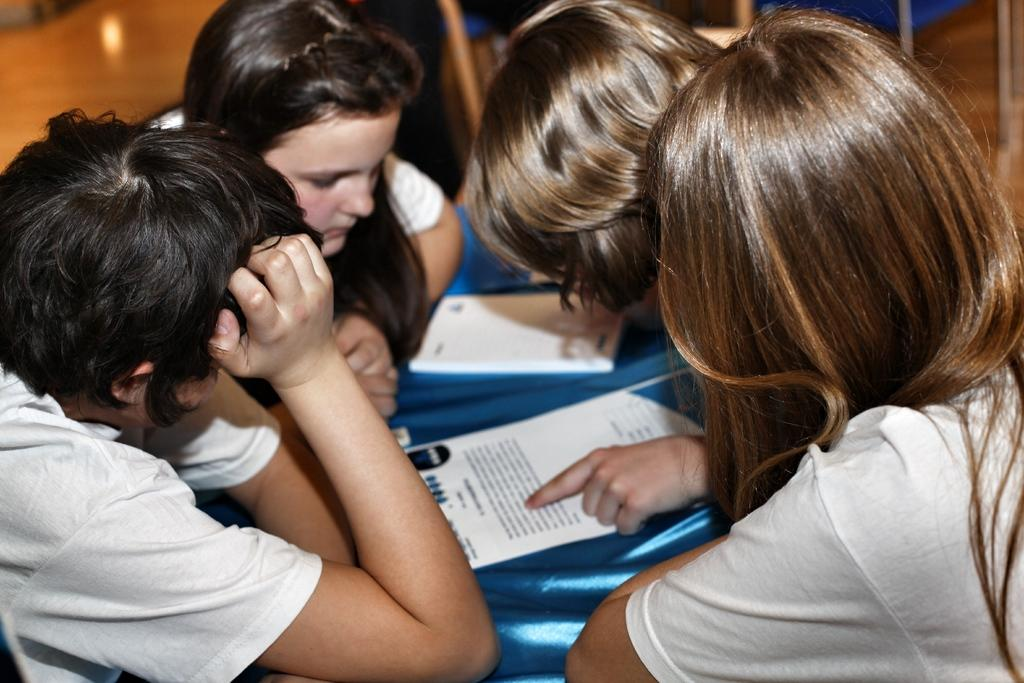How many people are sitting in the image? There are four persons sitting in the image. What can be seen in the middle of the image? There are papers in the middle of the image. Can you describe the seating arrangement of the persons in the image? Unfortunately, the seating arrangement cannot be determined from the provided facts. What type of skate is being used by one of the persons in the image? There is no skate present in the image; it features four persons sitting and papers in the middle. 